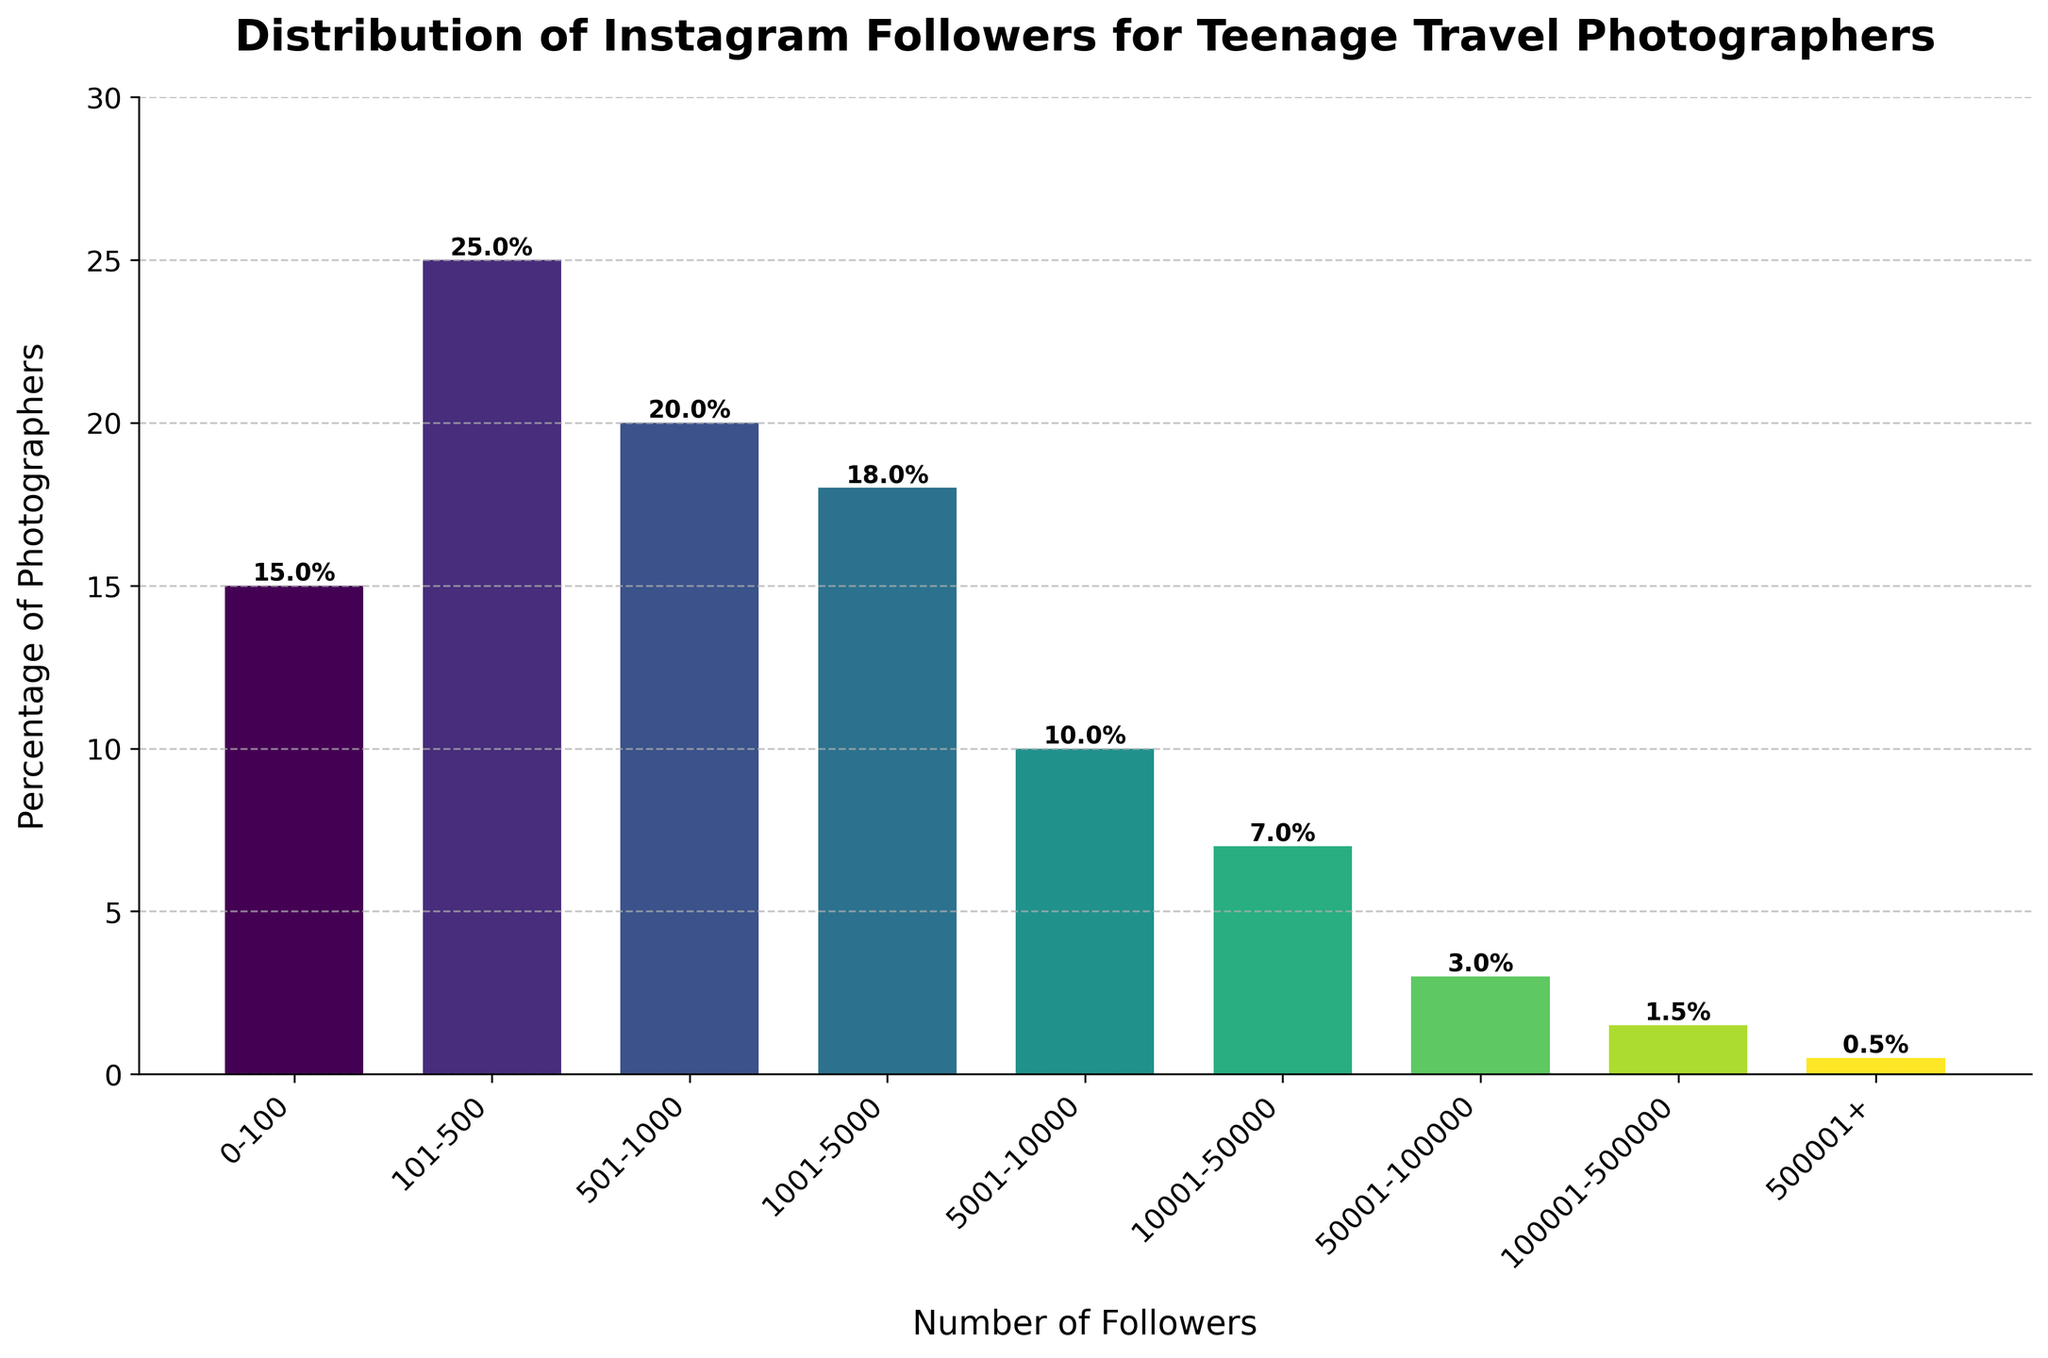Which follower range has the highest percentage of photographers? Look at the heights of the bars and identify the tallest one. The tallest bar represents the range with the highest percentage. The 101-500 follower range is the tallest.
Answer: 101-500 Which follower range has the lowest percentage of photographers? Look at the heights of the bars and identify the shortest one. The shortest bar represents the range with the lowest percentage. The 500001+ follower range is the shortest.
Answer: 500001+ What is the total percentage of photographers with fewer than 1000 followers? Sum the percentages of the first three bars (0-100, 101-500, 501-1000). 15% + 25% + 20% = 60%.
Answer: 60% How many percentage points higher is the percentage of photographers in the 101-500 range compared to the 50001-100000 range? Subtract the percentage of the 50001-100000 range from the 101-500 range. 25% - 3% = 22%.
Answer: 22% What is the average percentage of photographers in the ranges from 1001-5000 to 100001-500000? Add the percentages of these ranges and divide by the number of ranges. (18% + 10% + 7% + 3% + 1.5%) / 5 = 7.9%.
Answer: 7.9% Which follower range bar is colored the darkest? Identify the bar with the darkest shade. The darkest bar corresponds to the highest value in the color gradient, which is the last group: 500001+.
Answer: 500001+ Are there more photographers with 501-1000 followers or with 1001-5000 followers? Compare the heights of the bars for these two ranges. The bar for 501-1000 followers is taller than the bar for 1001-5000 followers.
Answer: 501-1000 What is the difference in percentage points between photographers with 101-500 followers and those with 50001-100000 followers? Subtract the percentage of photographers in the 50001-100000 range from the 101-500 range. 25% - 3% = 22%.
Answer: 22% What percentage of photographers have more than 100,000 followers? Sum the percentages of photographers in the 100001-500000 and 500001+ ranges. 1.5% + 0.5% = 2%.
Answer: 2% Which two consecutive follower ranges have the closest percentage values? Examine the differences in percentages between consecutive follower ranges. The smallest difference is between 5001-10000 and 10001-50000, which is 10% - 7% = 3%.
Answer: 5001-10000 and 10001-50000 